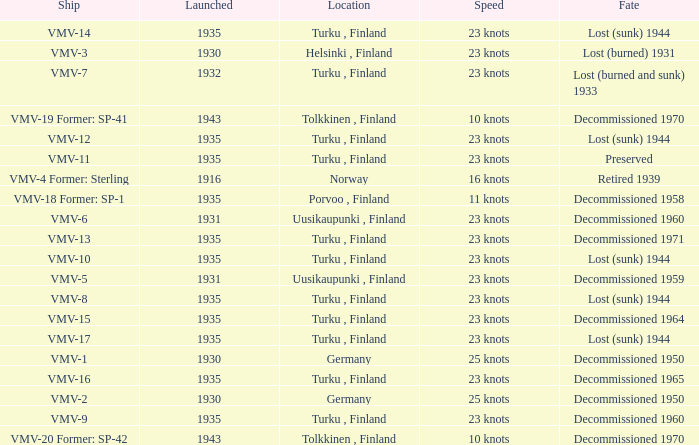What is the average launch date of the vmv-1 vessel in Germany? 1930.0. 